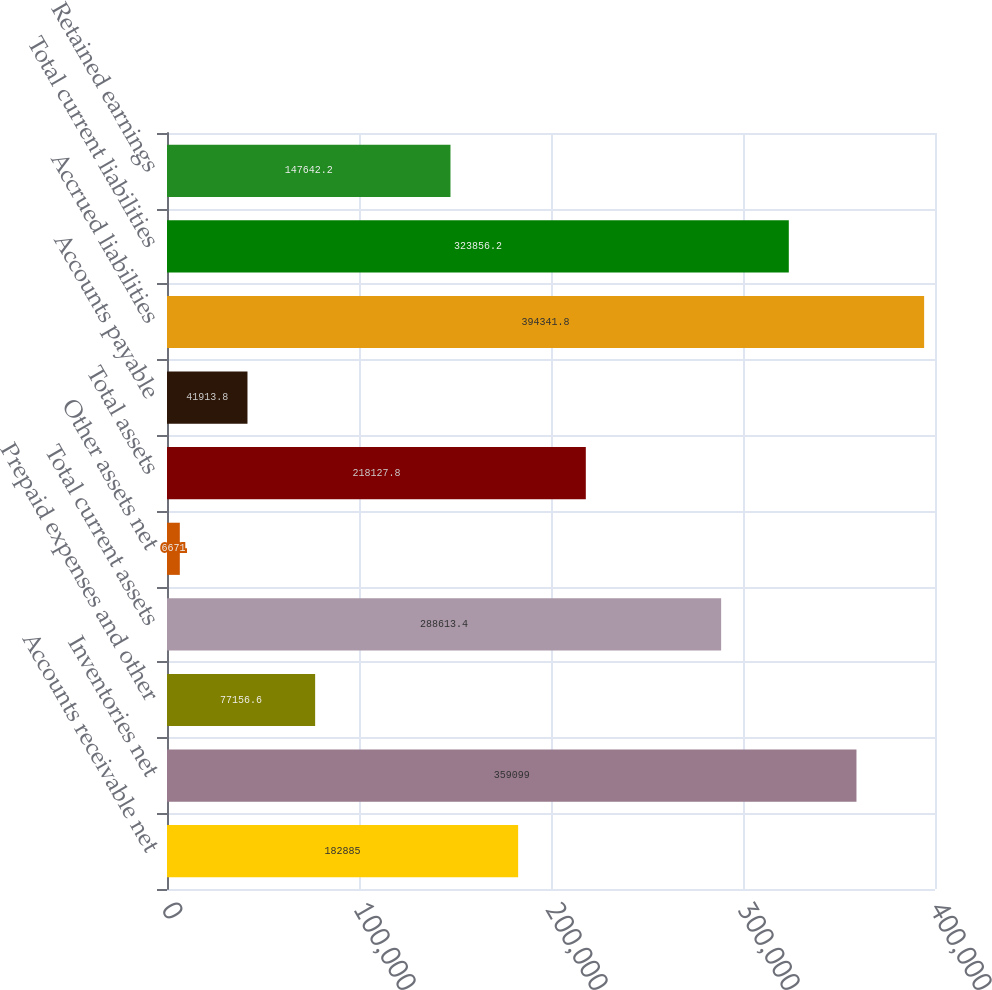Convert chart. <chart><loc_0><loc_0><loc_500><loc_500><bar_chart><fcel>Accounts receivable net<fcel>Inventories net<fcel>Prepaid expenses and other<fcel>Total current assets<fcel>Other assets net<fcel>Total assets<fcel>Accounts payable<fcel>Accrued liabilities<fcel>Total current liabilities<fcel>Retained earnings<nl><fcel>182885<fcel>359099<fcel>77156.6<fcel>288613<fcel>6671<fcel>218128<fcel>41913.8<fcel>394342<fcel>323856<fcel>147642<nl></chart> 